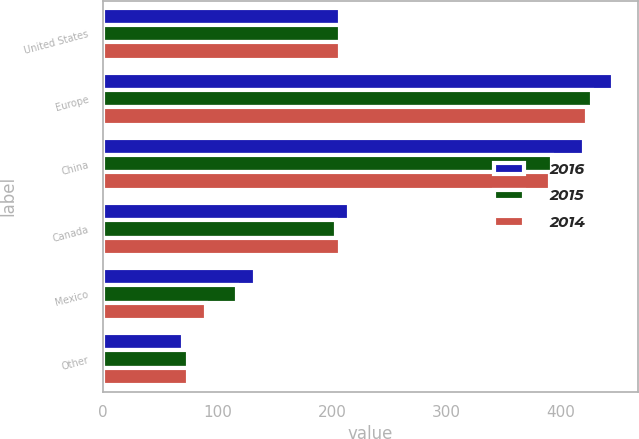<chart> <loc_0><loc_0><loc_500><loc_500><stacked_bar_chart><ecel><fcel>United States<fcel>Europe<fcel>China<fcel>Canada<fcel>Mexico<fcel>Other<nl><fcel>2016<fcel>206.5<fcel>445.2<fcel>420<fcel>215.1<fcel>132.8<fcel>69.4<nl><fcel>2015<fcel>206.5<fcel>426.8<fcel>392<fcel>203.1<fcel>117.3<fcel>74.3<nl><fcel>2014<fcel>206.5<fcel>422.7<fcel>390<fcel>206.5<fcel>90.1<fcel>74<nl></chart> 